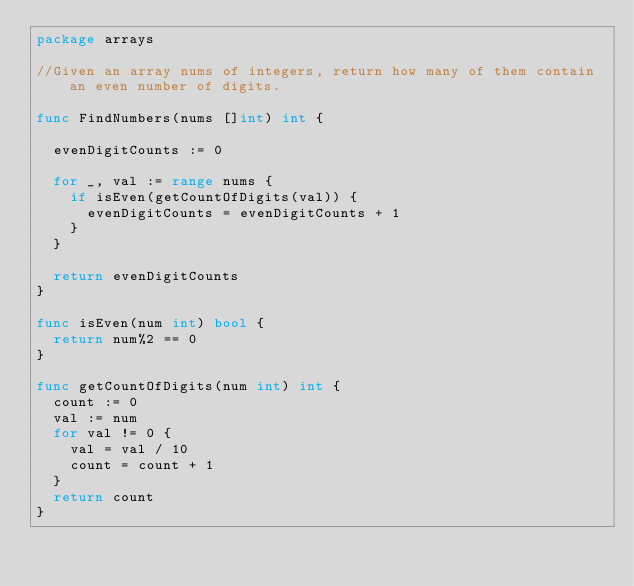Convert code to text. <code><loc_0><loc_0><loc_500><loc_500><_Go_>package arrays

//Given an array nums of integers, return how many of them contain an even number of digits.

func FindNumbers(nums []int) int {

	evenDigitCounts := 0

	for _, val := range nums {
		if isEven(getCountOfDigits(val)) {
			evenDigitCounts = evenDigitCounts + 1
		}
	}

	return evenDigitCounts
}

func isEven(num int) bool {
	return num%2 == 0
}

func getCountOfDigits(num int) int {
	count := 0
	val := num
	for val != 0 {
		val = val / 10
		count = count + 1
	}
	return count
}
</code> 